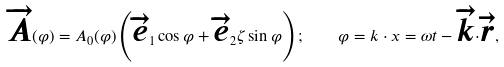Convert formula to latex. <formula><loc_0><loc_0><loc_500><loc_500>\overrightarrow { A } ( \varphi ) = A _ { 0 } ( \varphi ) \left ( \overrightarrow { e } _ { 1 } \cos \varphi + \overrightarrow { e } _ { 2 } \zeta \sin \varphi \right ) ; \quad \varphi = k \cdot x = \omega t - \overrightarrow { k } { \cdot } \overrightarrow { r } ,</formula> 